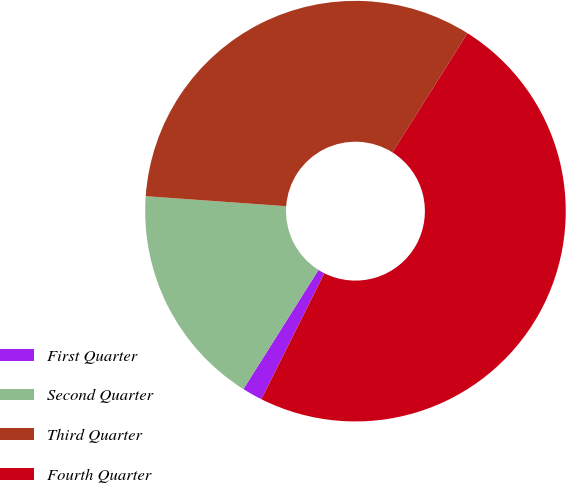Convert chart to OTSL. <chart><loc_0><loc_0><loc_500><loc_500><pie_chart><fcel>First Quarter<fcel>Second Quarter<fcel>Third Quarter<fcel>Fourth Quarter<nl><fcel>1.56%<fcel>17.19%<fcel>32.81%<fcel>48.44%<nl></chart> 